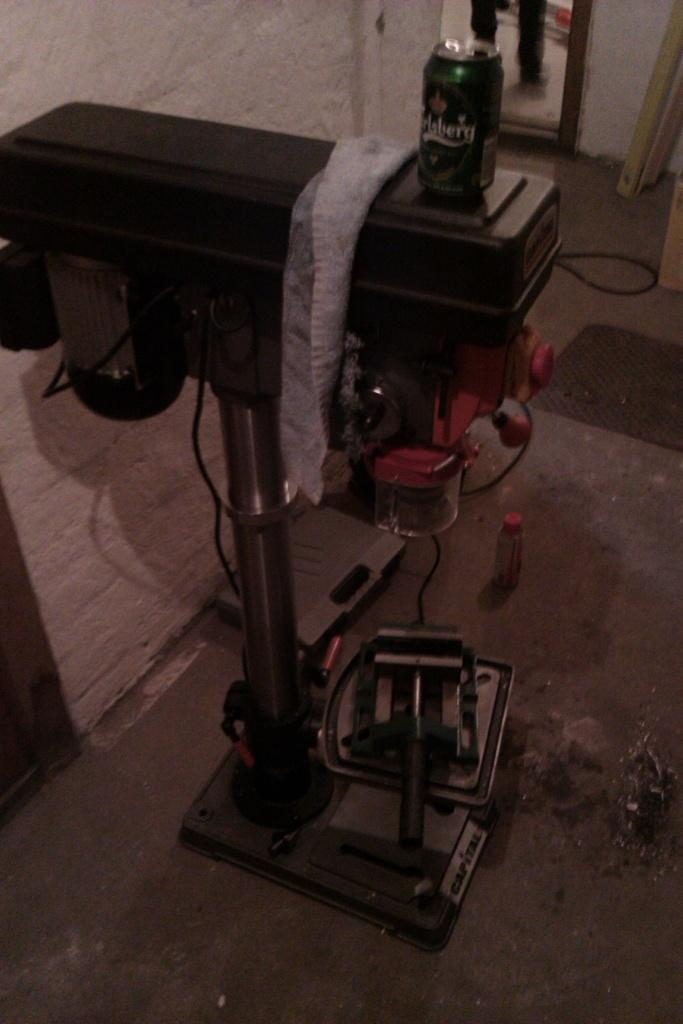<image>
Offer a succinct explanation of the picture presented. A room with a drink in it that looks like it says Ertsberg. 